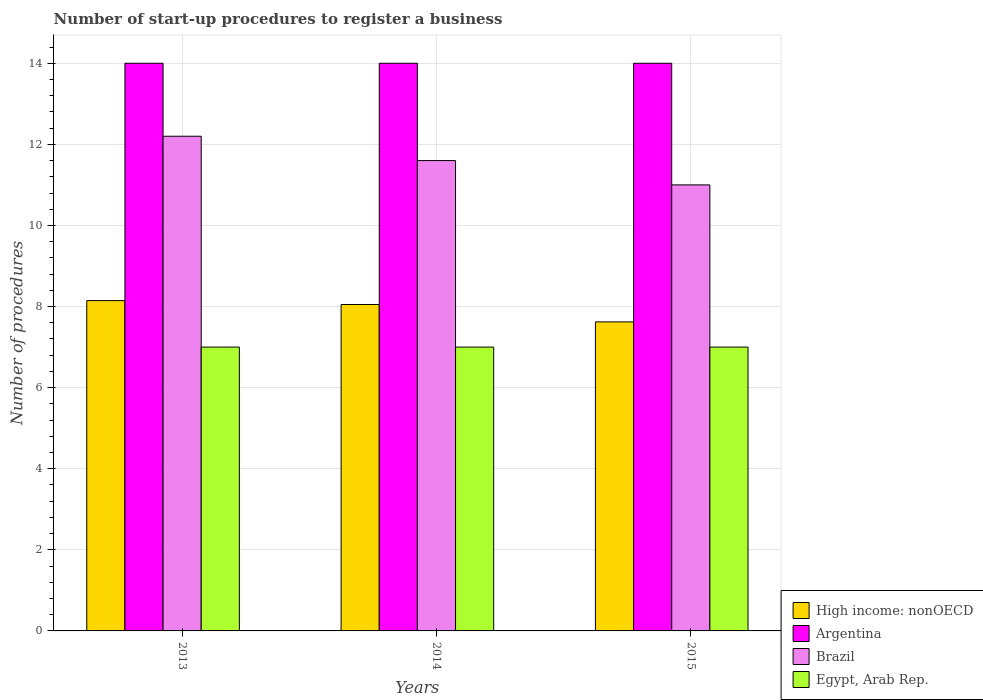Are the number of bars per tick equal to the number of legend labels?
Your response must be concise. Yes. Are the number of bars on each tick of the X-axis equal?
Make the answer very short. Yes. How many bars are there on the 3rd tick from the left?
Give a very brief answer. 4. What is the number of procedures required to register a business in Argentina in 2014?
Make the answer very short. 14. Across all years, what is the maximum number of procedures required to register a business in High income: nonOECD?
Your answer should be very brief. 8.15. Across all years, what is the minimum number of procedures required to register a business in Brazil?
Offer a terse response. 11. In which year was the number of procedures required to register a business in Brazil minimum?
Keep it short and to the point. 2015. What is the total number of procedures required to register a business in High income: nonOECD in the graph?
Offer a very short reply. 23.82. What is the difference between the number of procedures required to register a business in High income: nonOECD in 2014 and that in 2015?
Ensure brevity in your answer.  0.43. What is the difference between the number of procedures required to register a business in Argentina in 2014 and the number of procedures required to register a business in High income: nonOECD in 2013?
Provide a short and direct response. 5.85. What is the average number of procedures required to register a business in High income: nonOECD per year?
Offer a terse response. 7.94. In the year 2015, what is the difference between the number of procedures required to register a business in High income: nonOECD and number of procedures required to register a business in Brazil?
Offer a terse response. -3.38. In how many years, is the number of procedures required to register a business in Argentina greater than 12?
Provide a short and direct response. 3. What is the ratio of the number of procedures required to register a business in Egypt, Arab Rep. in 2013 to that in 2015?
Offer a terse response. 1. Is the difference between the number of procedures required to register a business in High income: nonOECD in 2013 and 2014 greater than the difference between the number of procedures required to register a business in Brazil in 2013 and 2014?
Ensure brevity in your answer.  No. What is the difference between the highest and the second highest number of procedures required to register a business in Argentina?
Make the answer very short. 0. What is the difference between the highest and the lowest number of procedures required to register a business in High income: nonOECD?
Keep it short and to the point. 0.52. Is the sum of the number of procedures required to register a business in Egypt, Arab Rep. in 2014 and 2015 greater than the maximum number of procedures required to register a business in Brazil across all years?
Ensure brevity in your answer.  Yes. Is it the case that in every year, the sum of the number of procedures required to register a business in High income: nonOECD and number of procedures required to register a business in Argentina is greater than the sum of number of procedures required to register a business in Egypt, Arab Rep. and number of procedures required to register a business in Brazil?
Give a very brief answer. No. What does the 1st bar from the left in 2015 represents?
Provide a short and direct response. High income: nonOECD. Are the values on the major ticks of Y-axis written in scientific E-notation?
Ensure brevity in your answer.  No. Does the graph contain any zero values?
Provide a short and direct response. No. Does the graph contain grids?
Offer a very short reply. Yes. Where does the legend appear in the graph?
Offer a terse response. Bottom right. How many legend labels are there?
Keep it short and to the point. 4. What is the title of the graph?
Ensure brevity in your answer.  Number of start-up procedures to register a business. What is the label or title of the X-axis?
Your answer should be very brief. Years. What is the label or title of the Y-axis?
Your response must be concise. Number of procedures. What is the Number of procedures of High income: nonOECD in 2013?
Provide a succinct answer. 8.15. What is the Number of procedures in Brazil in 2013?
Keep it short and to the point. 12.2. What is the Number of procedures in High income: nonOECD in 2014?
Offer a terse response. 8.05. What is the Number of procedures in Argentina in 2014?
Make the answer very short. 14. What is the Number of procedures in Egypt, Arab Rep. in 2014?
Provide a short and direct response. 7. What is the Number of procedures of High income: nonOECD in 2015?
Your answer should be very brief. 7.62. What is the Number of procedures in Brazil in 2015?
Give a very brief answer. 11. Across all years, what is the maximum Number of procedures in High income: nonOECD?
Provide a succinct answer. 8.15. Across all years, what is the maximum Number of procedures of Brazil?
Provide a short and direct response. 12.2. Across all years, what is the maximum Number of procedures in Egypt, Arab Rep.?
Your answer should be very brief. 7. Across all years, what is the minimum Number of procedures in High income: nonOECD?
Offer a terse response. 7.62. What is the total Number of procedures in High income: nonOECD in the graph?
Give a very brief answer. 23.82. What is the total Number of procedures of Argentina in the graph?
Offer a very short reply. 42. What is the total Number of procedures of Brazil in the graph?
Provide a succinct answer. 34.8. What is the difference between the Number of procedures in High income: nonOECD in 2013 and that in 2014?
Provide a succinct answer. 0.1. What is the difference between the Number of procedures of Brazil in 2013 and that in 2014?
Offer a very short reply. 0.6. What is the difference between the Number of procedures of High income: nonOECD in 2013 and that in 2015?
Make the answer very short. 0.53. What is the difference between the Number of procedures in High income: nonOECD in 2014 and that in 2015?
Your answer should be very brief. 0.43. What is the difference between the Number of procedures in Brazil in 2014 and that in 2015?
Provide a short and direct response. 0.6. What is the difference between the Number of procedures of Egypt, Arab Rep. in 2014 and that in 2015?
Keep it short and to the point. 0. What is the difference between the Number of procedures of High income: nonOECD in 2013 and the Number of procedures of Argentina in 2014?
Provide a succinct answer. -5.85. What is the difference between the Number of procedures in High income: nonOECD in 2013 and the Number of procedures in Brazil in 2014?
Make the answer very short. -3.45. What is the difference between the Number of procedures of High income: nonOECD in 2013 and the Number of procedures of Egypt, Arab Rep. in 2014?
Your answer should be very brief. 1.15. What is the difference between the Number of procedures of Argentina in 2013 and the Number of procedures of Brazil in 2014?
Keep it short and to the point. 2.4. What is the difference between the Number of procedures in High income: nonOECD in 2013 and the Number of procedures in Argentina in 2015?
Offer a terse response. -5.85. What is the difference between the Number of procedures in High income: nonOECD in 2013 and the Number of procedures in Brazil in 2015?
Keep it short and to the point. -2.85. What is the difference between the Number of procedures of High income: nonOECD in 2013 and the Number of procedures of Egypt, Arab Rep. in 2015?
Give a very brief answer. 1.15. What is the difference between the Number of procedures in Argentina in 2013 and the Number of procedures in Brazil in 2015?
Give a very brief answer. 3. What is the difference between the Number of procedures of Argentina in 2013 and the Number of procedures of Egypt, Arab Rep. in 2015?
Give a very brief answer. 7. What is the difference between the Number of procedures in High income: nonOECD in 2014 and the Number of procedures in Argentina in 2015?
Provide a succinct answer. -5.95. What is the difference between the Number of procedures of High income: nonOECD in 2014 and the Number of procedures of Brazil in 2015?
Your answer should be very brief. -2.95. What is the difference between the Number of procedures of High income: nonOECD in 2014 and the Number of procedures of Egypt, Arab Rep. in 2015?
Keep it short and to the point. 1.05. What is the average Number of procedures in High income: nonOECD per year?
Provide a short and direct response. 7.94. What is the average Number of procedures in Argentina per year?
Your answer should be very brief. 14. What is the average Number of procedures in Brazil per year?
Your answer should be compact. 11.6. What is the average Number of procedures of Egypt, Arab Rep. per year?
Ensure brevity in your answer.  7. In the year 2013, what is the difference between the Number of procedures in High income: nonOECD and Number of procedures in Argentina?
Ensure brevity in your answer.  -5.85. In the year 2013, what is the difference between the Number of procedures of High income: nonOECD and Number of procedures of Brazil?
Offer a terse response. -4.05. In the year 2013, what is the difference between the Number of procedures of High income: nonOECD and Number of procedures of Egypt, Arab Rep.?
Keep it short and to the point. 1.15. In the year 2013, what is the difference between the Number of procedures of Argentina and Number of procedures of Egypt, Arab Rep.?
Keep it short and to the point. 7. In the year 2013, what is the difference between the Number of procedures of Brazil and Number of procedures of Egypt, Arab Rep.?
Offer a terse response. 5.2. In the year 2014, what is the difference between the Number of procedures of High income: nonOECD and Number of procedures of Argentina?
Ensure brevity in your answer.  -5.95. In the year 2014, what is the difference between the Number of procedures in High income: nonOECD and Number of procedures in Brazil?
Offer a very short reply. -3.55. In the year 2014, what is the difference between the Number of procedures in Argentina and Number of procedures in Egypt, Arab Rep.?
Offer a very short reply. 7. In the year 2014, what is the difference between the Number of procedures of Brazil and Number of procedures of Egypt, Arab Rep.?
Offer a very short reply. 4.6. In the year 2015, what is the difference between the Number of procedures in High income: nonOECD and Number of procedures in Argentina?
Give a very brief answer. -6.38. In the year 2015, what is the difference between the Number of procedures of High income: nonOECD and Number of procedures of Brazil?
Make the answer very short. -3.38. In the year 2015, what is the difference between the Number of procedures of High income: nonOECD and Number of procedures of Egypt, Arab Rep.?
Your answer should be very brief. 0.62. In the year 2015, what is the difference between the Number of procedures of Argentina and Number of procedures of Egypt, Arab Rep.?
Ensure brevity in your answer.  7. What is the ratio of the Number of procedures in High income: nonOECD in 2013 to that in 2014?
Ensure brevity in your answer.  1.01. What is the ratio of the Number of procedures of Argentina in 2013 to that in 2014?
Your answer should be very brief. 1. What is the ratio of the Number of procedures of Brazil in 2013 to that in 2014?
Offer a very short reply. 1.05. What is the ratio of the Number of procedures in High income: nonOECD in 2013 to that in 2015?
Ensure brevity in your answer.  1.07. What is the ratio of the Number of procedures in Argentina in 2013 to that in 2015?
Offer a terse response. 1. What is the ratio of the Number of procedures of Brazil in 2013 to that in 2015?
Your answer should be compact. 1.11. What is the ratio of the Number of procedures of Egypt, Arab Rep. in 2013 to that in 2015?
Make the answer very short. 1. What is the ratio of the Number of procedures in High income: nonOECD in 2014 to that in 2015?
Your response must be concise. 1.06. What is the ratio of the Number of procedures in Brazil in 2014 to that in 2015?
Offer a very short reply. 1.05. What is the ratio of the Number of procedures of Egypt, Arab Rep. in 2014 to that in 2015?
Your answer should be very brief. 1. What is the difference between the highest and the second highest Number of procedures in High income: nonOECD?
Make the answer very short. 0.1. What is the difference between the highest and the second highest Number of procedures in Argentina?
Your answer should be very brief. 0. What is the difference between the highest and the second highest Number of procedures in Egypt, Arab Rep.?
Provide a succinct answer. 0. What is the difference between the highest and the lowest Number of procedures in High income: nonOECD?
Your response must be concise. 0.53. What is the difference between the highest and the lowest Number of procedures of Argentina?
Your answer should be compact. 0. 